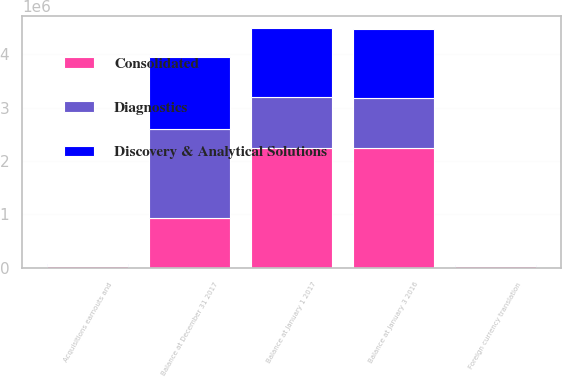<chart> <loc_0><loc_0><loc_500><loc_500><stacked_bar_chart><ecel><fcel>Balance at January 3 2016<fcel>Foreign currency translation<fcel>Acquisitions earnouts and<fcel>Balance at January 1 2017<fcel>Balance at December 31 2017<nl><fcel>Discovery & Analytical Solutions<fcel>1.29672e+06<fcel>16602<fcel>23814<fcel>1.30394e+06<fcel>1.34424e+06<nl><fcel>Diagnostics<fcel>940139<fcel>11873<fcel>15764<fcel>944030<fcel>1.65796e+06<nl><fcel>Consolidated<fcel>2.23686e+06<fcel>28475<fcel>39578<fcel>2.24797e+06<fcel>942084<nl></chart> 